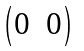Convert formula to latex. <formula><loc_0><loc_0><loc_500><loc_500>\begin{pmatrix} 0 & 0 \\ \end{pmatrix}</formula> 